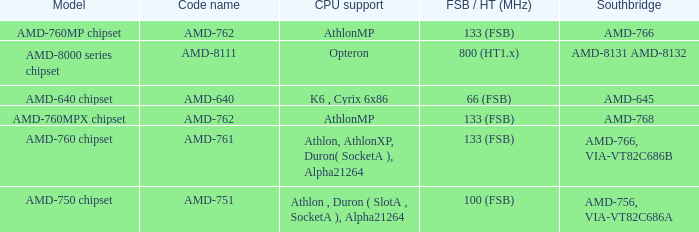Parse the full table. {'header': ['Model', 'Code name', 'CPU support', 'FSB / HT (MHz)', 'Southbridge'], 'rows': [['AMD-760MP chipset', 'AMD-762', 'AthlonMP', '133 (FSB)', 'AMD-766'], ['AMD-8000 series chipset', 'AMD-8111', 'Opteron', '800 (HT1.x)', 'AMD-8131 AMD-8132'], ['AMD-640 chipset', 'AMD-640', 'K6 , Cyrix 6x86', '66 (FSB)', 'AMD-645'], ['AMD-760MPX chipset', 'AMD-762', 'AthlonMP', '133 (FSB)', 'AMD-768'], ['AMD-760 chipset', 'AMD-761', 'Athlon, AthlonXP, Duron( SocketA ), Alpha21264', '133 (FSB)', 'AMD-766, VIA-VT82C686B'], ['AMD-750 chipset', 'AMD-751', 'Athlon , Duron ( SlotA , SocketA ), Alpha21264', '100 (FSB)', 'AMD-756, VIA-VT82C686A']]} What shows for Southbridge when the Model number is amd-640 chipset? AMD-645. 